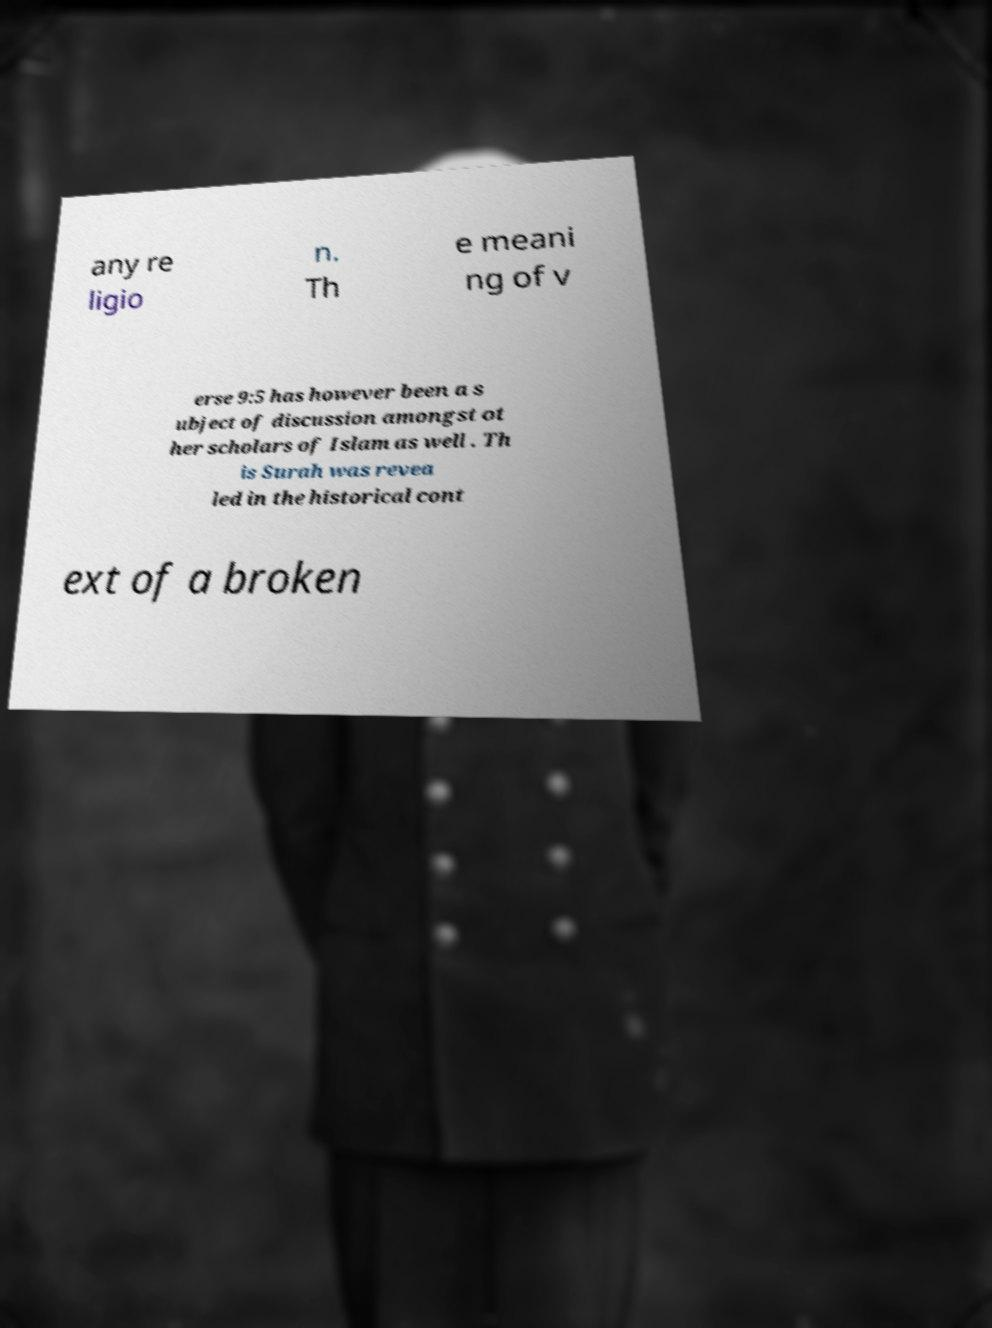Could you assist in decoding the text presented in this image and type it out clearly? any re ligio n. Th e meani ng of v erse 9:5 has however been a s ubject of discussion amongst ot her scholars of Islam as well . Th is Surah was revea led in the historical cont ext of a broken 